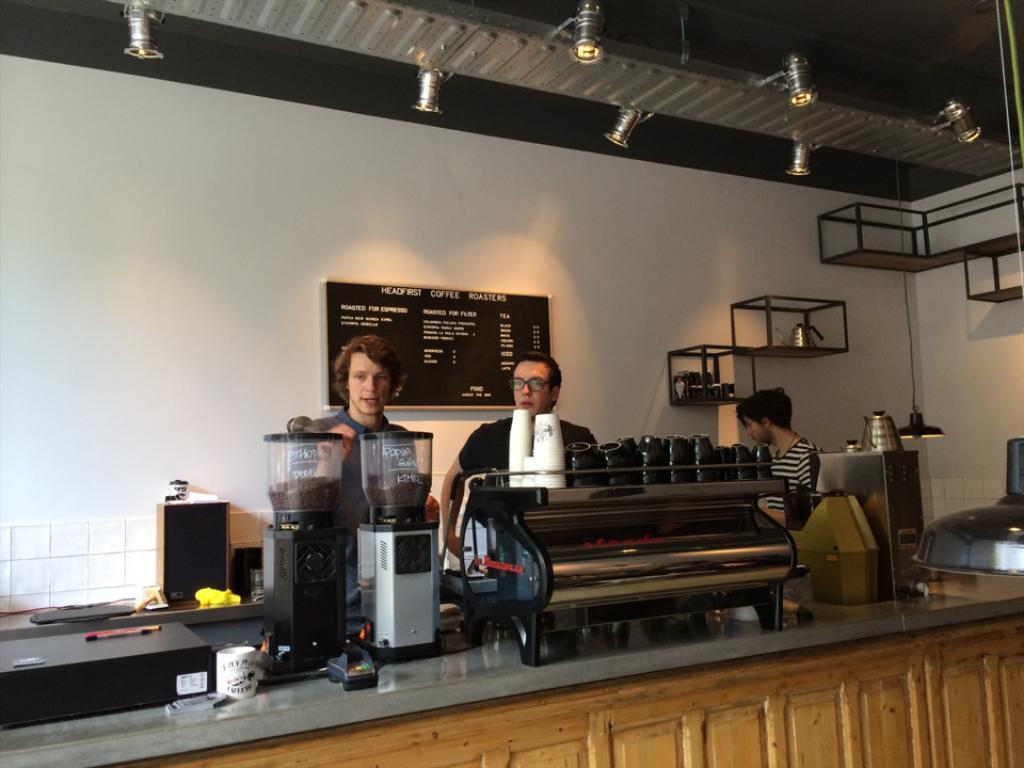<image>
Provide a brief description of the given image. Two men stand in front of the menu board at Head First Coffee Roasters. 